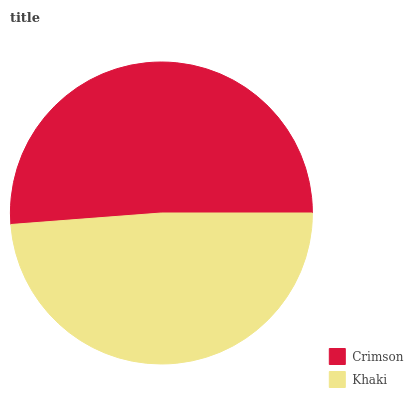Is Khaki the minimum?
Answer yes or no. Yes. Is Crimson the maximum?
Answer yes or no. Yes. Is Khaki the maximum?
Answer yes or no. No. Is Crimson greater than Khaki?
Answer yes or no. Yes. Is Khaki less than Crimson?
Answer yes or no. Yes. Is Khaki greater than Crimson?
Answer yes or no. No. Is Crimson less than Khaki?
Answer yes or no. No. Is Crimson the high median?
Answer yes or no. Yes. Is Khaki the low median?
Answer yes or no. Yes. Is Khaki the high median?
Answer yes or no. No. Is Crimson the low median?
Answer yes or no. No. 